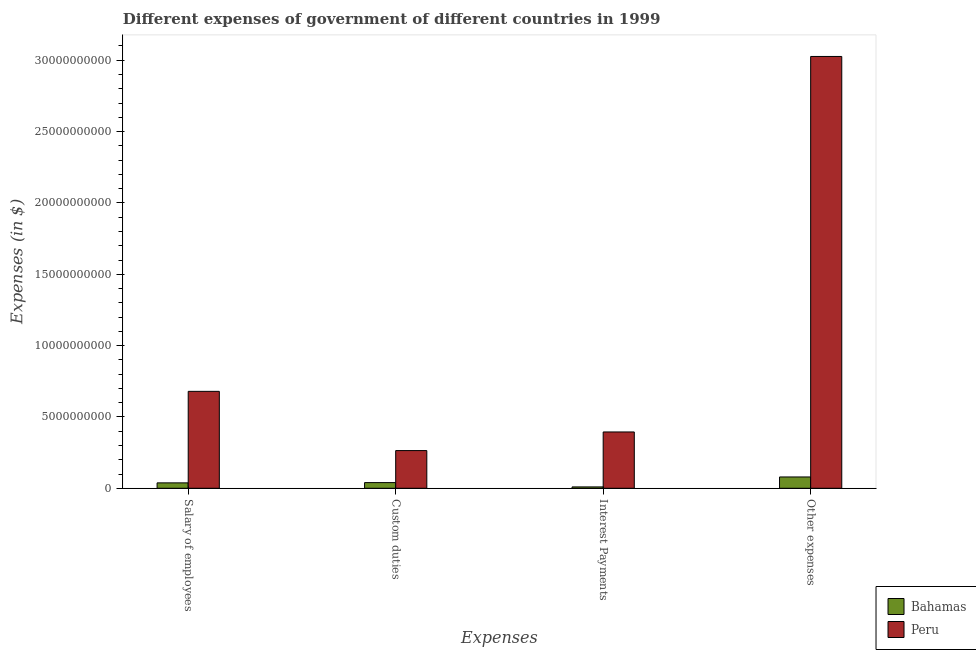How many bars are there on the 1st tick from the left?
Offer a very short reply. 2. What is the label of the 1st group of bars from the left?
Offer a terse response. Salary of employees. What is the amount spent on custom duties in Bahamas?
Provide a succinct answer. 3.98e+08. Across all countries, what is the maximum amount spent on other expenses?
Ensure brevity in your answer.  3.03e+1. Across all countries, what is the minimum amount spent on other expenses?
Offer a terse response. 7.94e+08. In which country was the amount spent on salary of employees minimum?
Give a very brief answer. Bahamas. What is the total amount spent on salary of employees in the graph?
Provide a succinct answer. 7.17e+09. What is the difference between the amount spent on custom duties in Peru and that in Bahamas?
Keep it short and to the point. 2.24e+09. What is the difference between the amount spent on salary of employees in Peru and the amount spent on other expenses in Bahamas?
Make the answer very short. 6.00e+09. What is the average amount spent on interest payments per country?
Your answer should be compact. 2.02e+09. What is the difference between the amount spent on custom duties and amount spent on interest payments in Peru?
Your answer should be compact. -1.31e+09. What is the ratio of the amount spent on salary of employees in Bahamas to that in Peru?
Provide a succinct answer. 0.06. What is the difference between the highest and the second highest amount spent on other expenses?
Your response must be concise. 2.95e+1. What is the difference between the highest and the lowest amount spent on salary of employees?
Offer a terse response. 6.41e+09. Is the sum of the amount spent on custom duties in Bahamas and Peru greater than the maximum amount spent on salary of employees across all countries?
Offer a very short reply. No. Are all the bars in the graph horizontal?
Your response must be concise. No. What is the difference between two consecutive major ticks on the Y-axis?
Your answer should be very brief. 5.00e+09. Are the values on the major ticks of Y-axis written in scientific E-notation?
Your answer should be compact. No. Where does the legend appear in the graph?
Ensure brevity in your answer.  Bottom right. How are the legend labels stacked?
Give a very brief answer. Vertical. What is the title of the graph?
Ensure brevity in your answer.  Different expenses of government of different countries in 1999. What is the label or title of the X-axis?
Provide a succinct answer. Expenses. What is the label or title of the Y-axis?
Ensure brevity in your answer.  Expenses (in $). What is the Expenses (in $) in Bahamas in Salary of employees?
Give a very brief answer. 3.80e+08. What is the Expenses (in $) of Peru in Salary of employees?
Your answer should be very brief. 6.79e+09. What is the Expenses (in $) in Bahamas in Custom duties?
Ensure brevity in your answer.  3.98e+08. What is the Expenses (in $) of Peru in Custom duties?
Make the answer very short. 2.64e+09. What is the Expenses (in $) of Bahamas in Interest Payments?
Keep it short and to the point. 9.56e+07. What is the Expenses (in $) of Peru in Interest Payments?
Give a very brief answer. 3.95e+09. What is the Expenses (in $) in Bahamas in Other expenses?
Provide a short and direct response. 7.94e+08. What is the Expenses (in $) in Peru in Other expenses?
Offer a terse response. 3.03e+1. Across all Expenses, what is the maximum Expenses (in $) in Bahamas?
Your response must be concise. 7.94e+08. Across all Expenses, what is the maximum Expenses (in $) in Peru?
Ensure brevity in your answer.  3.03e+1. Across all Expenses, what is the minimum Expenses (in $) of Bahamas?
Offer a terse response. 9.56e+07. Across all Expenses, what is the minimum Expenses (in $) of Peru?
Your answer should be very brief. 2.64e+09. What is the total Expenses (in $) of Bahamas in the graph?
Your answer should be very brief. 1.67e+09. What is the total Expenses (in $) in Peru in the graph?
Offer a terse response. 4.36e+1. What is the difference between the Expenses (in $) in Bahamas in Salary of employees and that in Custom duties?
Make the answer very short. -1.87e+07. What is the difference between the Expenses (in $) of Peru in Salary of employees and that in Custom duties?
Provide a succinct answer. 4.15e+09. What is the difference between the Expenses (in $) of Bahamas in Salary of employees and that in Interest Payments?
Make the answer very short. 2.84e+08. What is the difference between the Expenses (in $) of Peru in Salary of employees and that in Interest Payments?
Give a very brief answer. 2.85e+09. What is the difference between the Expenses (in $) in Bahamas in Salary of employees and that in Other expenses?
Make the answer very short. -4.14e+08. What is the difference between the Expenses (in $) in Peru in Salary of employees and that in Other expenses?
Give a very brief answer. -2.35e+1. What is the difference between the Expenses (in $) in Bahamas in Custom duties and that in Interest Payments?
Your answer should be compact. 3.03e+08. What is the difference between the Expenses (in $) in Peru in Custom duties and that in Interest Payments?
Provide a succinct answer. -1.31e+09. What is the difference between the Expenses (in $) of Bahamas in Custom duties and that in Other expenses?
Make the answer very short. -3.95e+08. What is the difference between the Expenses (in $) in Peru in Custom duties and that in Other expenses?
Offer a very short reply. -2.76e+1. What is the difference between the Expenses (in $) of Bahamas in Interest Payments and that in Other expenses?
Offer a terse response. -6.98e+08. What is the difference between the Expenses (in $) of Peru in Interest Payments and that in Other expenses?
Provide a short and direct response. -2.63e+1. What is the difference between the Expenses (in $) in Bahamas in Salary of employees and the Expenses (in $) in Peru in Custom duties?
Your answer should be very brief. -2.26e+09. What is the difference between the Expenses (in $) in Bahamas in Salary of employees and the Expenses (in $) in Peru in Interest Payments?
Ensure brevity in your answer.  -3.57e+09. What is the difference between the Expenses (in $) in Bahamas in Salary of employees and the Expenses (in $) in Peru in Other expenses?
Ensure brevity in your answer.  -2.99e+1. What is the difference between the Expenses (in $) in Bahamas in Custom duties and the Expenses (in $) in Peru in Interest Payments?
Make the answer very short. -3.55e+09. What is the difference between the Expenses (in $) of Bahamas in Custom duties and the Expenses (in $) of Peru in Other expenses?
Your answer should be very brief. -2.99e+1. What is the difference between the Expenses (in $) in Bahamas in Interest Payments and the Expenses (in $) in Peru in Other expenses?
Give a very brief answer. -3.02e+1. What is the average Expenses (in $) in Bahamas per Expenses?
Ensure brevity in your answer.  4.17e+08. What is the average Expenses (in $) in Peru per Expenses?
Provide a succinct answer. 1.09e+1. What is the difference between the Expenses (in $) of Bahamas and Expenses (in $) of Peru in Salary of employees?
Your response must be concise. -6.41e+09. What is the difference between the Expenses (in $) in Bahamas and Expenses (in $) in Peru in Custom duties?
Provide a succinct answer. -2.24e+09. What is the difference between the Expenses (in $) in Bahamas and Expenses (in $) in Peru in Interest Payments?
Offer a very short reply. -3.85e+09. What is the difference between the Expenses (in $) in Bahamas and Expenses (in $) in Peru in Other expenses?
Provide a short and direct response. -2.95e+1. What is the ratio of the Expenses (in $) in Bahamas in Salary of employees to that in Custom duties?
Your answer should be compact. 0.95. What is the ratio of the Expenses (in $) in Peru in Salary of employees to that in Custom duties?
Your answer should be very brief. 2.57. What is the ratio of the Expenses (in $) of Bahamas in Salary of employees to that in Interest Payments?
Your answer should be very brief. 3.97. What is the ratio of the Expenses (in $) in Peru in Salary of employees to that in Interest Payments?
Ensure brevity in your answer.  1.72. What is the ratio of the Expenses (in $) in Bahamas in Salary of employees to that in Other expenses?
Provide a short and direct response. 0.48. What is the ratio of the Expenses (in $) of Peru in Salary of employees to that in Other expenses?
Give a very brief answer. 0.22. What is the ratio of the Expenses (in $) of Bahamas in Custom duties to that in Interest Payments?
Make the answer very short. 4.17. What is the ratio of the Expenses (in $) of Peru in Custom duties to that in Interest Payments?
Your response must be concise. 0.67. What is the ratio of the Expenses (in $) in Bahamas in Custom duties to that in Other expenses?
Make the answer very short. 0.5. What is the ratio of the Expenses (in $) of Peru in Custom duties to that in Other expenses?
Offer a very short reply. 0.09. What is the ratio of the Expenses (in $) of Bahamas in Interest Payments to that in Other expenses?
Give a very brief answer. 0.12. What is the ratio of the Expenses (in $) in Peru in Interest Payments to that in Other expenses?
Make the answer very short. 0.13. What is the difference between the highest and the second highest Expenses (in $) in Bahamas?
Your answer should be very brief. 3.95e+08. What is the difference between the highest and the second highest Expenses (in $) of Peru?
Make the answer very short. 2.35e+1. What is the difference between the highest and the lowest Expenses (in $) in Bahamas?
Provide a succinct answer. 6.98e+08. What is the difference between the highest and the lowest Expenses (in $) of Peru?
Offer a terse response. 2.76e+1. 